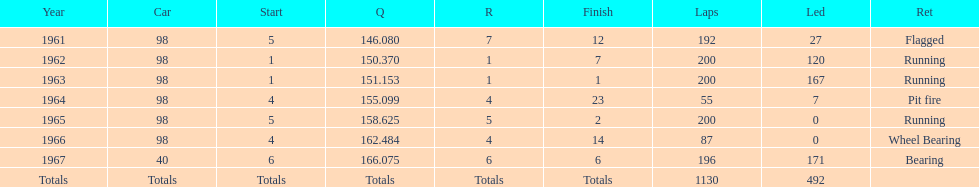How many times did he finish in the top three? 2. Help me parse the entirety of this table. {'header': ['Year', 'Car', 'Start', 'Q', 'R', 'Finish', 'Laps', 'Led', 'Ret'], 'rows': [['1961', '98', '5', '146.080', '7', '12', '192', '27', 'Flagged'], ['1962', '98', '1', '150.370', '1', '7', '200', '120', 'Running'], ['1963', '98', '1', '151.153', '1', '1', '200', '167', 'Running'], ['1964', '98', '4', '155.099', '4', '23', '55', '7', 'Pit fire'], ['1965', '98', '5', '158.625', '5', '2', '200', '0', 'Running'], ['1966', '98', '4', '162.484', '4', '14', '87', '0', 'Wheel Bearing'], ['1967', '40', '6', '166.075', '6', '6', '196', '171', 'Bearing'], ['Totals', 'Totals', 'Totals', 'Totals', 'Totals', 'Totals', '1130', '492', '']]} 